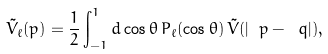<formula> <loc_0><loc_0><loc_500><loc_500>\tilde { V } _ { \ell } ( p ) = \frac { 1 } { 2 } \int _ { - 1 } ^ { 1 } d \cos \theta \, P _ { \ell } ( \cos \theta ) \, \tilde { V } ( | \ p - \ q | ) ,</formula> 